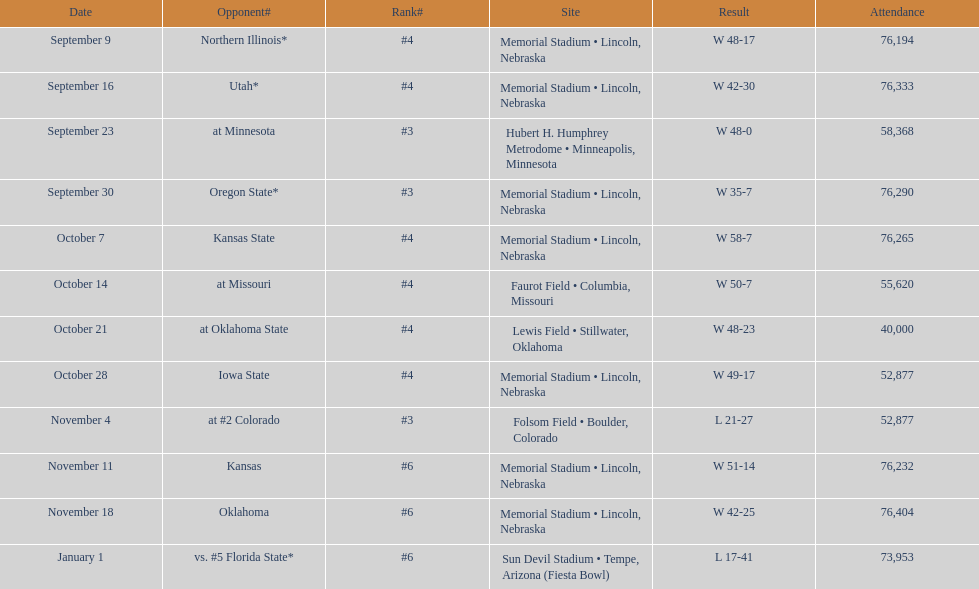When can we expect the first game to occur? September 9. 